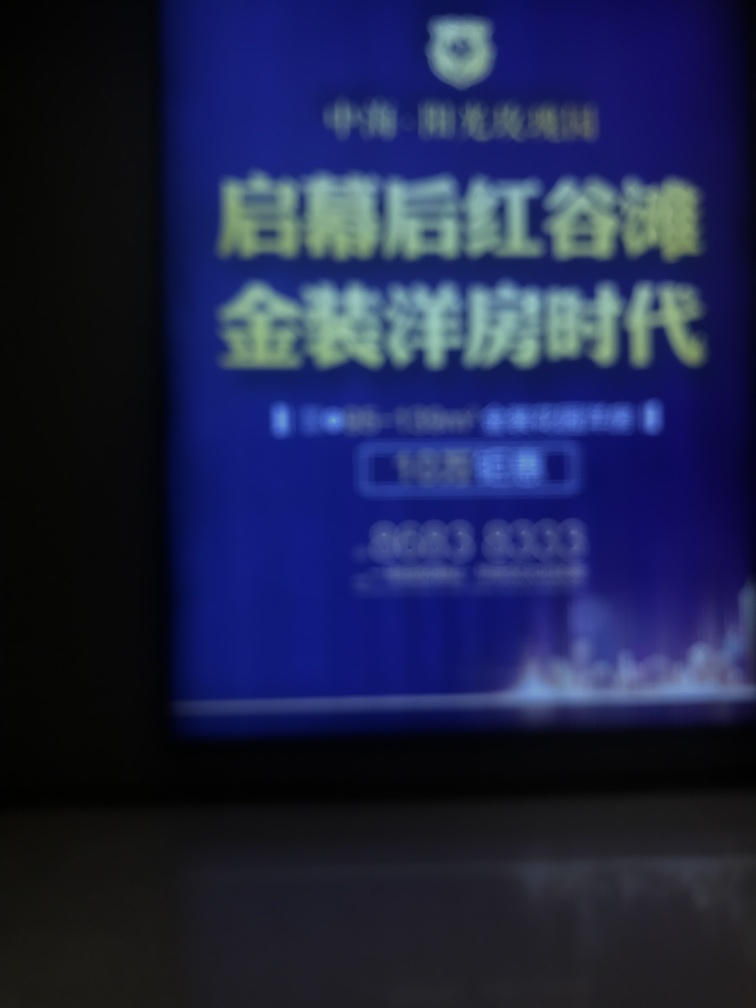Is there any discernible text or symbols in the image that can be made out despite the blurriness? Due to the blurriness of the image, it's challenging to accurately identify any text or symbols. In cases like this, a higher resolution or more focused photo would be required for proper examination. 